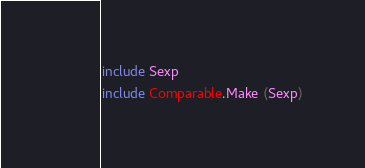Convert code to text. <code><loc_0><loc_0><loc_500><loc_500><_OCaml_>include Sexp
include Comparable.Make (Sexp)
</code> 